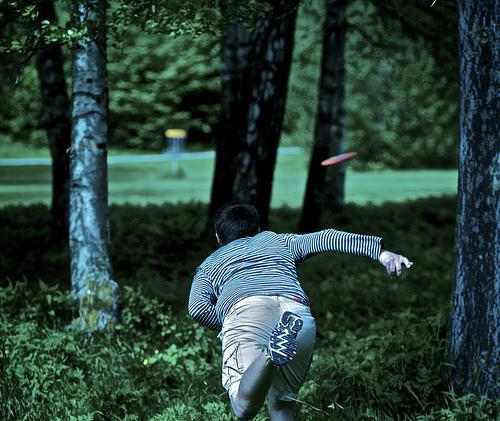Question: what is the man throwing?
Choices:
A. Toy.
B. Frisbee.
C. Item.
D. Sports toy.
Answer with the letter. Answer: B Question: what color is the Frisbee?
Choices:
A. Red.
B. White.
C. Yellow.
D. Purple.
Answer with the letter. Answer: A Question: how many frisbees are in the picture?
Choices:
A. One.
B. Two.
C. Three.
D. Four.
Answer with the letter. Answer: A Question: where is this picture taken?
Choices:
A. Near street.
B. In park.
C. Place with benches.
D. Near people.
Answer with the letter. Answer: B Question: why is man leaning foward?
Choices:
A. He's falling.
B. To throw.
C. To show off.
D. Just threw.
Answer with the letter. Answer: D 